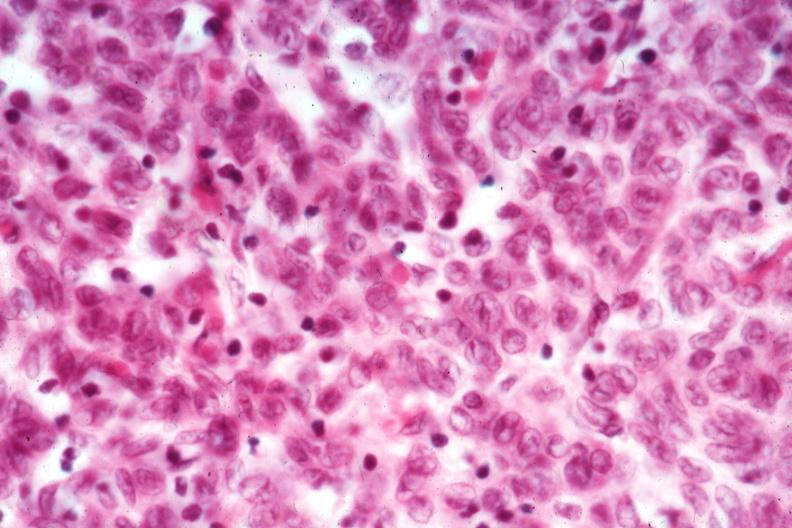does metastatic carcinoma oat cell show cell detail good epithelial dominance?
Answer the question using a single word or phrase. No 